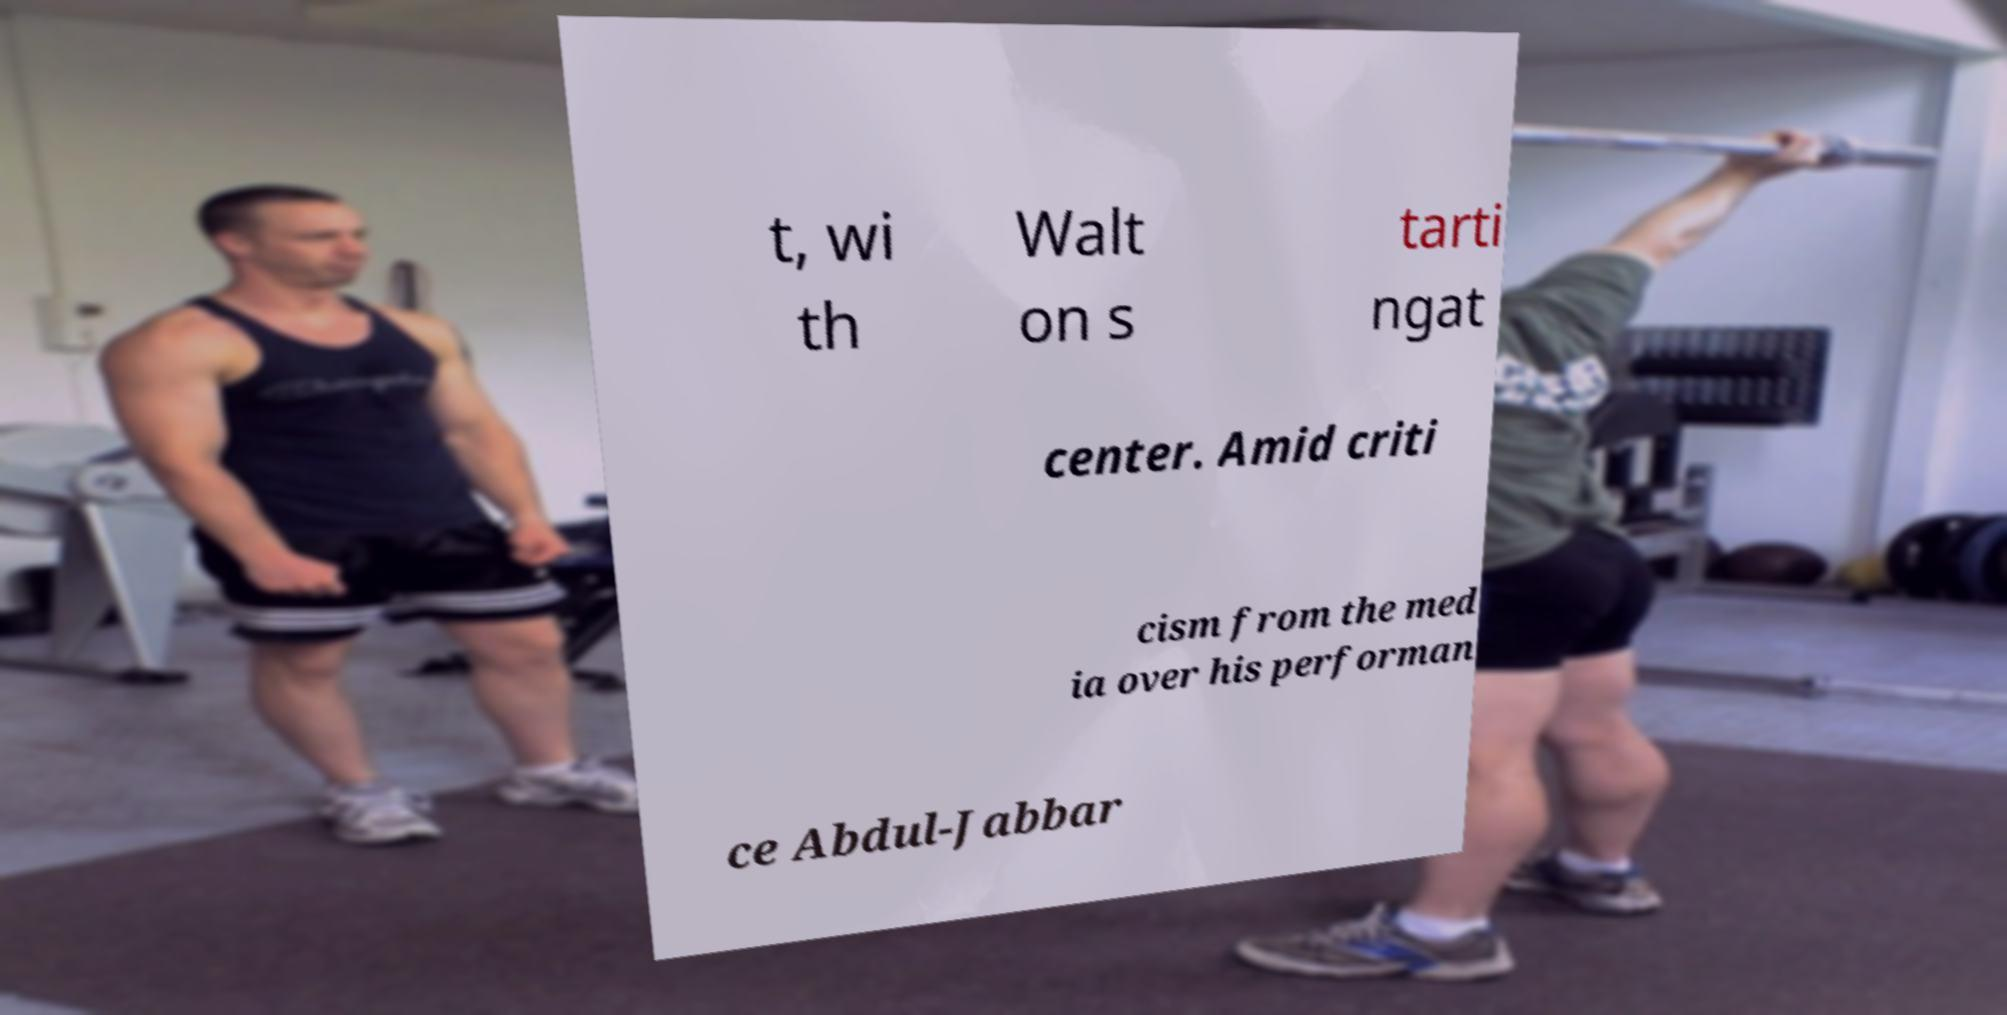I need the written content from this picture converted into text. Can you do that? t, wi th Walt on s tarti ngat center. Amid criti cism from the med ia over his performan ce Abdul-Jabbar 